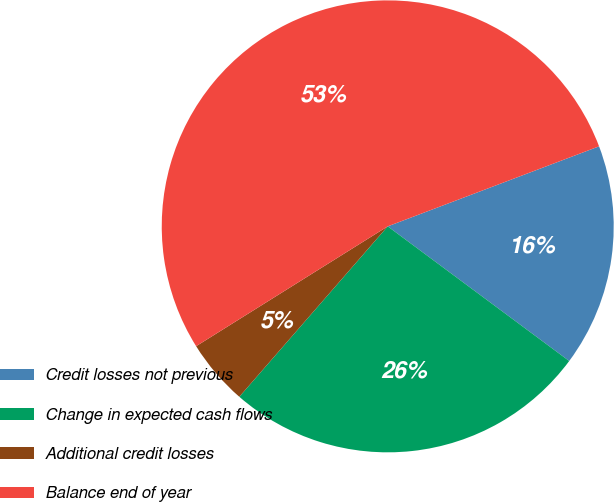Convert chart. <chart><loc_0><loc_0><loc_500><loc_500><pie_chart><fcel>Credit losses not previous<fcel>Change in expected cash flows<fcel>Additional credit losses<fcel>Balance end of year<nl><fcel>15.92%<fcel>26.24%<fcel>4.7%<fcel>53.13%<nl></chart> 